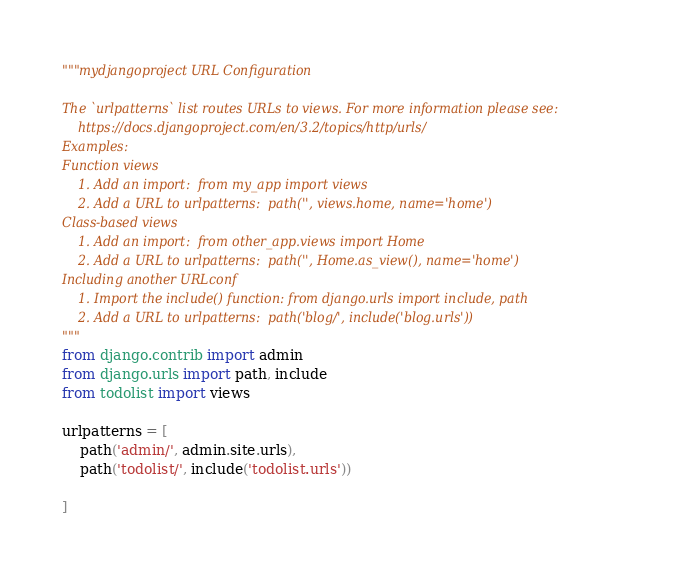<code> <loc_0><loc_0><loc_500><loc_500><_Python_>"""mydjangoproject URL Configuration

The `urlpatterns` list routes URLs to views. For more information please see:
    https://docs.djangoproject.com/en/3.2/topics/http/urls/
Examples:
Function views
    1. Add an import:  from my_app import views
    2. Add a URL to urlpatterns:  path('', views.home, name='home')
Class-based views
    1. Add an import:  from other_app.views import Home
    2. Add a URL to urlpatterns:  path('', Home.as_view(), name='home')
Including another URLconf
    1. Import the include() function: from django.urls import include, path
    2. Add a URL to urlpatterns:  path('blog/', include('blog.urls'))
"""
from django.contrib import admin
from django.urls import path, include
from todolist import views

urlpatterns = [
    path('admin/', admin.site.urls),
    path('todolist/', include('todolist.urls'))

]
</code> 